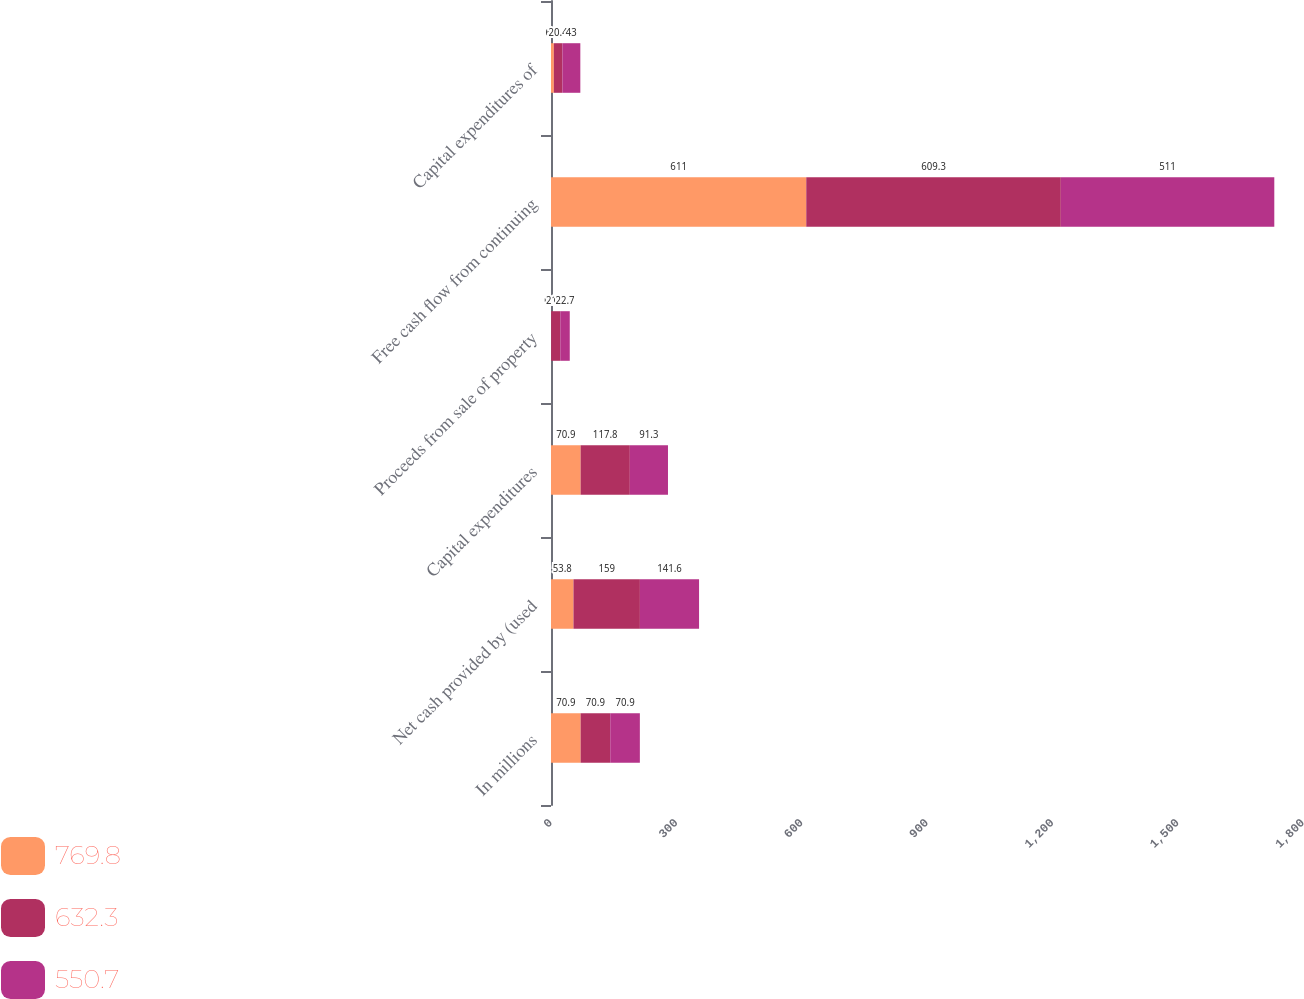<chart> <loc_0><loc_0><loc_500><loc_500><stacked_bar_chart><ecel><fcel>In millions<fcel>Net cash provided by (used<fcel>Capital expenditures<fcel>Proceeds from sale of property<fcel>Free cash flow from continuing<fcel>Capital expenditures of<nl><fcel>769.8<fcel>70.9<fcel>53.8<fcel>70.9<fcel>0.3<fcel>611<fcel>6.8<nl><fcel>632.3<fcel>70.9<fcel>159<fcel>117.8<fcel>21.9<fcel>609.3<fcel>20.4<nl><fcel>550.7<fcel>70.9<fcel>141.6<fcel>91.3<fcel>22.7<fcel>511<fcel>43<nl></chart> 